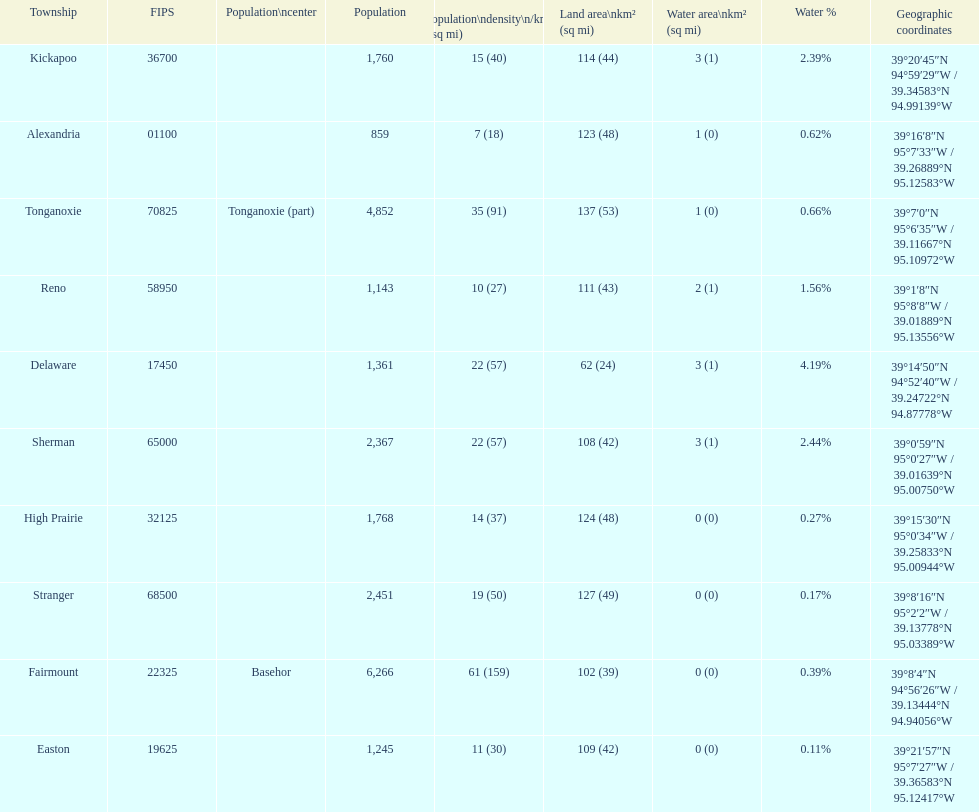Which township has the least land area? Delaware. 